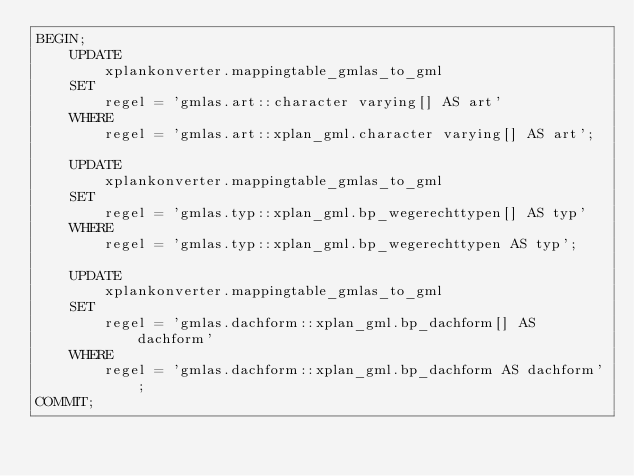<code> <loc_0><loc_0><loc_500><loc_500><_SQL_>BEGIN;
    UPDATE
        xplankonverter.mappingtable_gmlas_to_gml
    SET
        regel = 'gmlas.art::character varying[] AS art'
    WHERE
        regel = 'gmlas.art::xplan_gml.character varying[] AS art';

    UPDATE
        xplankonverter.mappingtable_gmlas_to_gml
    SET
        regel = 'gmlas.typ::xplan_gml.bp_wegerechttypen[] AS typ'
    WHERE
        regel = 'gmlas.typ::xplan_gml.bp_wegerechttypen AS typ';

    UPDATE
        xplankonverter.mappingtable_gmlas_to_gml
    SET
        regel = 'gmlas.dachform::xplan_gml.bp_dachform[] AS dachform'
    WHERE
        regel = 'gmlas.dachform::xplan_gml.bp_dachform AS dachform';
COMMIT;</code> 